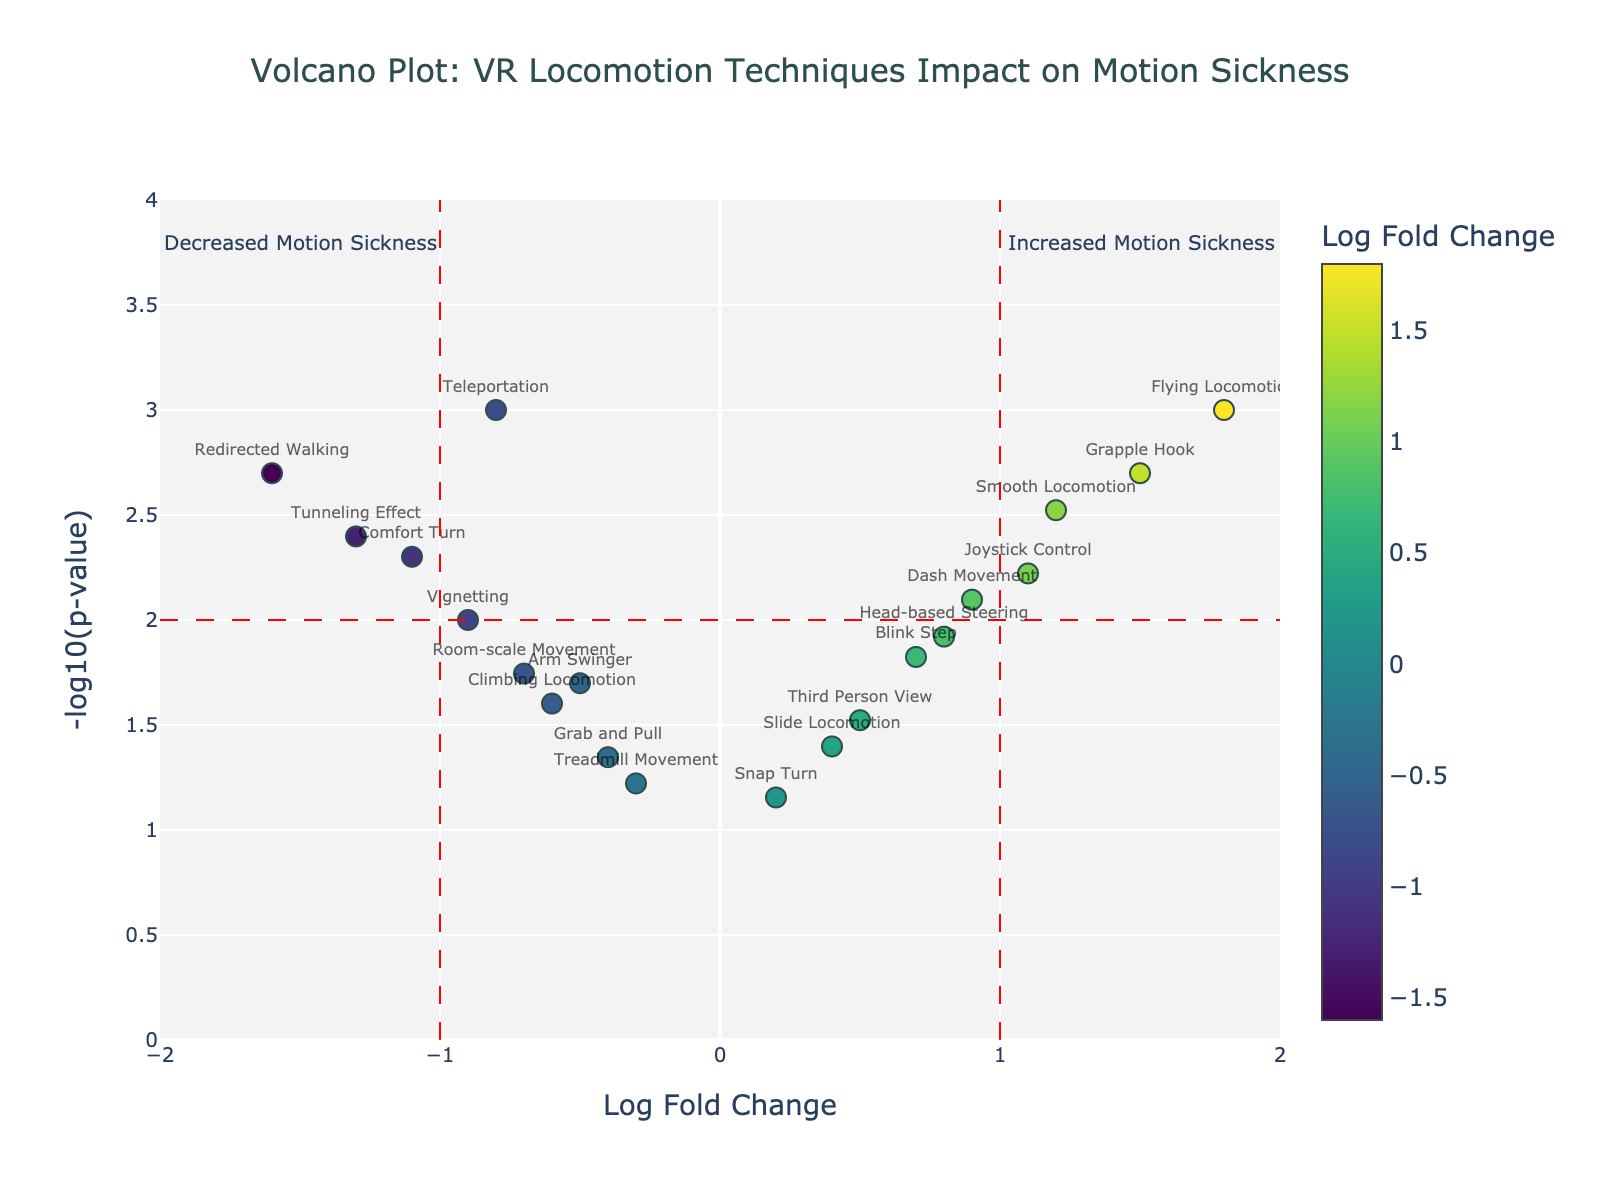What is the title of the figure? Look at the top center of the figure to find the title.
Answer: Volcano Plot: VR Locomotion Techniques Impact on Motion Sickness Which VR locomotion technique has the highest log fold change? Locate the gene with the highest value on the x-axis (LogFoldChange).
Answer: Flying Locomotion What does a negative log fold change indicate about a VR locomotion technique's impact on motion sickness? Refer to the annotation on the left side of the figure.
Answer: Decreased Motion Sickness Which VR locomotion technique shows the most significant decrease in motion sickness and what is its p-value? Identify the data point farthest left along the x-axis and check its y-axis value for significance.
Answer: Redirected Walking, p-value is 0.002 How many VR locomotion techniques have a p-value less than 0.01? Count the data points that lie above -log10(p-value)=2 horizontal line on the y-axis.
Answer: 10 Which techniques fall within the threshold lines for increased motion sickness? Identify data points between x=1 and further right.
Answer: Smooth Locomotion, Dash Movement, Grapple Hook, Flying Locomotion, Joystick Control, Head-based Steering Compare the log fold change of 'Sliding Locomotion' and 'Blink Step'. Which one is higher? Check the positions of these techniques along the x-axis and compare.
Answer: Blink Step Which VR locomotion techniques fall below the threshold line of p-value = 0.01 for being statistically significant? Identify data points lying below the horizontal line at y=2.
Answer: Treadmill Movement, Snap Turn, Grab and Pull What color represents the least log fold change on the marker color scale? Look at the color scale legend on the right to find the color corresponding to the lowest value.
Answer: Dark blue Out of all techniques listed, which one shows the highest negative log fold change affecting motion sickness? Find the point farthest left and note its fold change value.
Answer: Redirected Walking (log fold change = -1.6) 